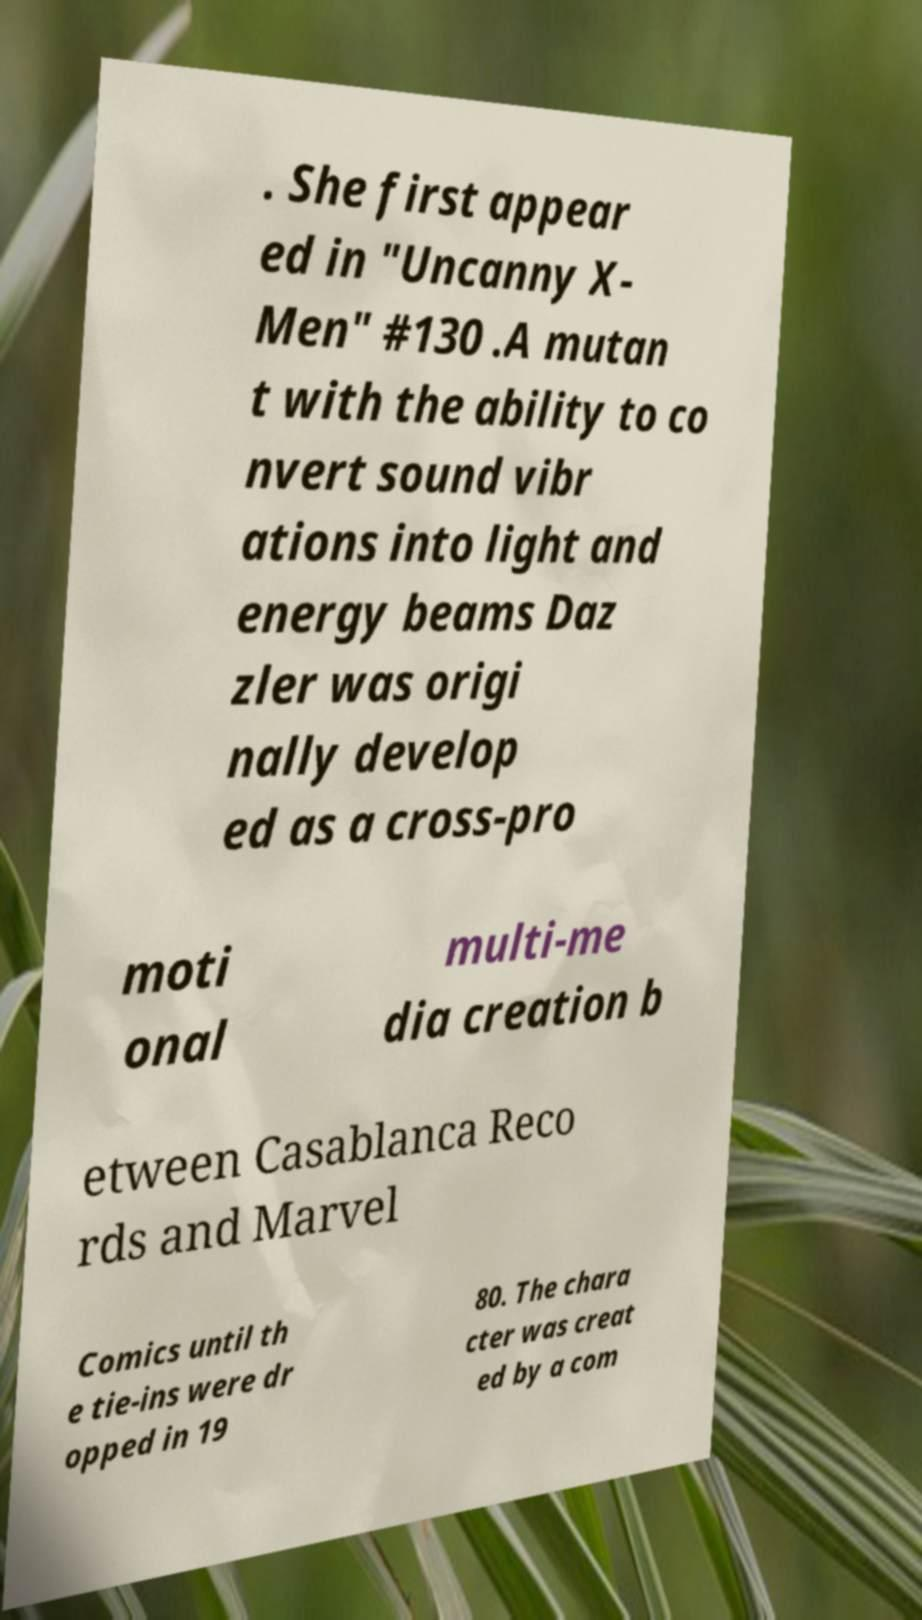Could you extract and type out the text from this image? . She first appear ed in "Uncanny X- Men" #130 .A mutan t with the ability to co nvert sound vibr ations into light and energy beams Daz zler was origi nally develop ed as a cross-pro moti onal multi-me dia creation b etween Casablanca Reco rds and Marvel Comics until th e tie-ins were dr opped in 19 80. The chara cter was creat ed by a com 